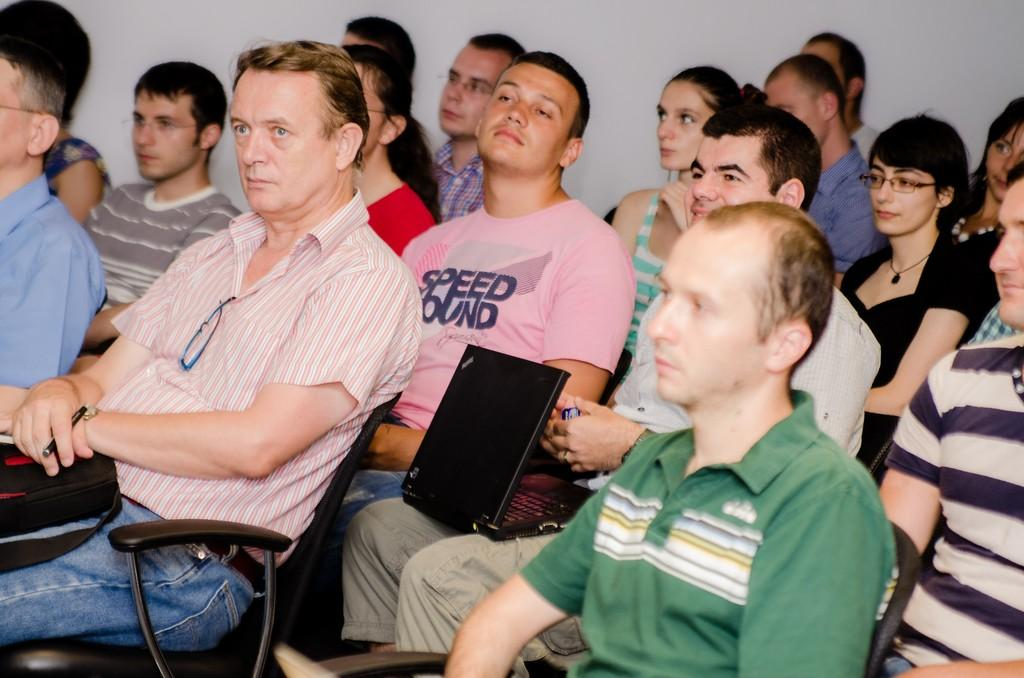How many people are in the image? There is a group of people in the image. What are the people doing in the image? The people are sitting on chairs. What electronic device can be seen in the image? There is a laptop in the image. What is the color of the wall in the image? There is a white color wall in the image. Can you describe any other objects present in the image? There are other objects present in the image, but their specific details are not mentioned in the provided facts. What type of sock is the person wearing on their left foot in the image? There is no information about socks or any person's footwear in the provided facts, so it cannot be determined from the image. 